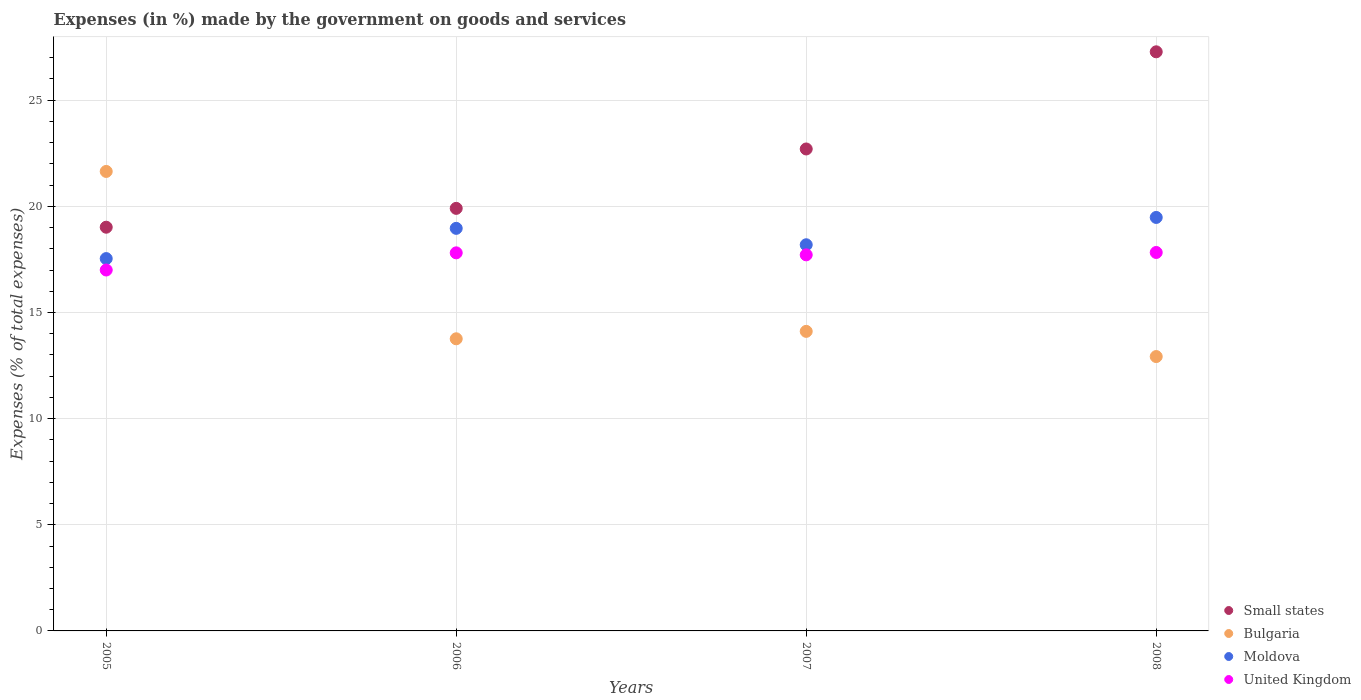Is the number of dotlines equal to the number of legend labels?
Your response must be concise. Yes. What is the percentage of expenses made by the government on goods and services in United Kingdom in 2006?
Give a very brief answer. 17.81. Across all years, what is the maximum percentage of expenses made by the government on goods and services in United Kingdom?
Provide a succinct answer. 17.83. Across all years, what is the minimum percentage of expenses made by the government on goods and services in Bulgaria?
Make the answer very short. 12.92. What is the total percentage of expenses made by the government on goods and services in Moldova in the graph?
Offer a very short reply. 74.17. What is the difference between the percentage of expenses made by the government on goods and services in Moldova in 2007 and that in 2008?
Provide a short and direct response. -1.29. What is the difference between the percentage of expenses made by the government on goods and services in Small states in 2005 and the percentage of expenses made by the government on goods and services in Bulgaria in 2007?
Offer a terse response. 4.91. What is the average percentage of expenses made by the government on goods and services in Small states per year?
Offer a very short reply. 22.22. In the year 2008, what is the difference between the percentage of expenses made by the government on goods and services in United Kingdom and percentage of expenses made by the government on goods and services in Bulgaria?
Make the answer very short. 4.9. What is the ratio of the percentage of expenses made by the government on goods and services in Bulgaria in 2006 to that in 2008?
Provide a succinct answer. 1.06. Is the percentage of expenses made by the government on goods and services in Moldova in 2007 less than that in 2008?
Offer a terse response. Yes. What is the difference between the highest and the second highest percentage of expenses made by the government on goods and services in United Kingdom?
Your answer should be very brief. 0.02. What is the difference between the highest and the lowest percentage of expenses made by the government on goods and services in United Kingdom?
Provide a short and direct response. 0.83. Does the percentage of expenses made by the government on goods and services in United Kingdom monotonically increase over the years?
Your response must be concise. No. Is the percentage of expenses made by the government on goods and services in United Kingdom strictly greater than the percentage of expenses made by the government on goods and services in Moldova over the years?
Make the answer very short. No. Is the percentage of expenses made by the government on goods and services in Small states strictly less than the percentage of expenses made by the government on goods and services in Moldova over the years?
Provide a short and direct response. No. How many dotlines are there?
Your response must be concise. 4. How many years are there in the graph?
Provide a succinct answer. 4. What is the difference between two consecutive major ticks on the Y-axis?
Your answer should be very brief. 5. Are the values on the major ticks of Y-axis written in scientific E-notation?
Provide a short and direct response. No. Does the graph contain any zero values?
Ensure brevity in your answer.  No. Does the graph contain grids?
Give a very brief answer. Yes. How are the legend labels stacked?
Ensure brevity in your answer.  Vertical. What is the title of the graph?
Provide a short and direct response. Expenses (in %) made by the government on goods and services. Does "Monaco" appear as one of the legend labels in the graph?
Provide a short and direct response. No. What is the label or title of the X-axis?
Provide a short and direct response. Years. What is the label or title of the Y-axis?
Ensure brevity in your answer.  Expenses (% of total expenses). What is the Expenses (% of total expenses) of Small states in 2005?
Make the answer very short. 19.02. What is the Expenses (% of total expenses) in Bulgaria in 2005?
Give a very brief answer. 21.64. What is the Expenses (% of total expenses) in Moldova in 2005?
Your answer should be very brief. 17.54. What is the Expenses (% of total expenses) of United Kingdom in 2005?
Keep it short and to the point. 17. What is the Expenses (% of total expenses) in Small states in 2006?
Ensure brevity in your answer.  19.9. What is the Expenses (% of total expenses) of Bulgaria in 2006?
Give a very brief answer. 13.76. What is the Expenses (% of total expenses) of Moldova in 2006?
Provide a succinct answer. 18.96. What is the Expenses (% of total expenses) of United Kingdom in 2006?
Keep it short and to the point. 17.81. What is the Expenses (% of total expenses) in Small states in 2007?
Offer a terse response. 22.7. What is the Expenses (% of total expenses) of Bulgaria in 2007?
Keep it short and to the point. 14.11. What is the Expenses (% of total expenses) in Moldova in 2007?
Provide a succinct answer. 18.19. What is the Expenses (% of total expenses) in United Kingdom in 2007?
Your answer should be compact. 17.71. What is the Expenses (% of total expenses) of Small states in 2008?
Your response must be concise. 27.28. What is the Expenses (% of total expenses) of Bulgaria in 2008?
Offer a terse response. 12.92. What is the Expenses (% of total expenses) of Moldova in 2008?
Provide a succinct answer. 19.48. What is the Expenses (% of total expenses) of United Kingdom in 2008?
Your answer should be very brief. 17.83. Across all years, what is the maximum Expenses (% of total expenses) in Small states?
Make the answer very short. 27.28. Across all years, what is the maximum Expenses (% of total expenses) in Bulgaria?
Keep it short and to the point. 21.64. Across all years, what is the maximum Expenses (% of total expenses) of Moldova?
Your response must be concise. 19.48. Across all years, what is the maximum Expenses (% of total expenses) in United Kingdom?
Your answer should be very brief. 17.83. Across all years, what is the minimum Expenses (% of total expenses) of Small states?
Provide a succinct answer. 19.02. Across all years, what is the minimum Expenses (% of total expenses) of Bulgaria?
Your response must be concise. 12.92. Across all years, what is the minimum Expenses (% of total expenses) in Moldova?
Keep it short and to the point. 17.54. Across all years, what is the minimum Expenses (% of total expenses) in United Kingdom?
Your answer should be compact. 17. What is the total Expenses (% of total expenses) in Small states in the graph?
Ensure brevity in your answer.  88.9. What is the total Expenses (% of total expenses) of Bulgaria in the graph?
Your answer should be very brief. 62.44. What is the total Expenses (% of total expenses) of Moldova in the graph?
Keep it short and to the point. 74.17. What is the total Expenses (% of total expenses) in United Kingdom in the graph?
Your answer should be compact. 70.35. What is the difference between the Expenses (% of total expenses) in Small states in 2005 and that in 2006?
Ensure brevity in your answer.  -0.89. What is the difference between the Expenses (% of total expenses) of Bulgaria in 2005 and that in 2006?
Your answer should be very brief. 7.88. What is the difference between the Expenses (% of total expenses) in Moldova in 2005 and that in 2006?
Your answer should be very brief. -1.42. What is the difference between the Expenses (% of total expenses) of United Kingdom in 2005 and that in 2006?
Offer a terse response. -0.81. What is the difference between the Expenses (% of total expenses) of Small states in 2005 and that in 2007?
Give a very brief answer. -3.69. What is the difference between the Expenses (% of total expenses) in Bulgaria in 2005 and that in 2007?
Offer a very short reply. 7.53. What is the difference between the Expenses (% of total expenses) of Moldova in 2005 and that in 2007?
Provide a succinct answer. -0.65. What is the difference between the Expenses (% of total expenses) of United Kingdom in 2005 and that in 2007?
Ensure brevity in your answer.  -0.71. What is the difference between the Expenses (% of total expenses) in Small states in 2005 and that in 2008?
Keep it short and to the point. -8.26. What is the difference between the Expenses (% of total expenses) in Bulgaria in 2005 and that in 2008?
Your answer should be very brief. 8.72. What is the difference between the Expenses (% of total expenses) of Moldova in 2005 and that in 2008?
Your answer should be compact. -1.94. What is the difference between the Expenses (% of total expenses) in United Kingdom in 2005 and that in 2008?
Provide a short and direct response. -0.83. What is the difference between the Expenses (% of total expenses) of Small states in 2006 and that in 2007?
Provide a succinct answer. -2.8. What is the difference between the Expenses (% of total expenses) in Bulgaria in 2006 and that in 2007?
Make the answer very short. -0.35. What is the difference between the Expenses (% of total expenses) in Moldova in 2006 and that in 2007?
Make the answer very short. 0.77. What is the difference between the Expenses (% of total expenses) of United Kingdom in 2006 and that in 2007?
Your answer should be compact. 0.09. What is the difference between the Expenses (% of total expenses) of Small states in 2006 and that in 2008?
Give a very brief answer. -7.37. What is the difference between the Expenses (% of total expenses) of Bulgaria in 2006 and that in 2008?
Ensure brevity in your answer.  0.84. What is the difference between the Expenses (% of total expenses) in Moldova in 2006 and that in 2008?
Ensure brevity in your answer.  -0.51. What is the difference between the Expenses (% of total expenses) of United Kingdom in 2006 and that in 2008?
Give a very brief answer. -0.02. What is the difference between the Expenses (% of total expenses) in Small states in 2007 and that in 2008?
Give a very brief answer. -4.58. What is the difference between the Expenses (% of total expenses) in Bulgaria in 2007 and that in 2008?
Keep it short and to the point. 1.19. What is the difference between the Expenses (% of total expenses) of Moldova in 2007 and that in 2008?
Keep it short and to the point. -1.29. What is the difference between the Expenses (% of total expenses) of United Kingdom in 2007 and that in 2008?
Make the answer very short. -0.11. What is the difference between the Expenses (% of total expenses) in Small states in 2005 and the Expenses (% of total expenses) in Bulgaria in 2006?
Provide a succinct answer. 5.26. What is the difference between the Expenses (% of total expenses) in Small states in 2005 and the Expenses (% of total expenses) in Moldova in 2006?
Your answer should be very brief. 0.05. What is the difference between the Expenses (% of total expenses) in Small states in 2005 and the Expenses (% of total expenses) in United Kingdom in 2006?
Keep it short and to the point. 1.21. What is the difference between the Expenses (% of total expenses) of Bulgaria in 2005 and the Expenses (% of total expenses) of Moldova in 2006?
Offer a very short reply. 2.68. What is the difference between the Expenses (% of total expenses) in Bulgaria in 2005 and the Expenses (% of total expenses) in United Kingdom in 2006?
Offer a very short reply. 3.83. What is the difference between the Expenses (% of total expenses) of Moldova in 2005 and the Expenses (% of total expenses) of United Kingdom in 2006?
Make the answer very short. -0.27. What is the difference between the Expenses (% of total expenses) of Small states in 2005 and the Expenses (% of total expenses) of Bulgaria in 2007?
Provide a short and direct response. 4.91. What is the difference between the Expenses (% of total expenses) of Small states in 2005 and the Expenses (% of total expenses) of Moldova in 2007?
Offer a very short reply. 0.83. What is the difference between the Expenses (% of total expenses) of Small states in 2005 and the Expenses (% of total expenses) of United Kingdom in 2007?
Your response must be concise. 1.3. What is the difference between the Expenses (% of total expenses) in Bulgaria in 2005 and the Expenses (% of total expenses) in Moldova in 2007?
Your answer should be compact. 3.45. What is the difference between the Expenses (% of total expenses) of Bulgaria in 2005 and the Expenses (% of total expenses) of United Kingdom in 2007?
Provide a succinct answer. 3.93. What is the difference between the Expenses (% of total expenses) of Moldova in 2005 and the Expenses (% of total expenses) of United Kingdom in 2007?
Your answer should be compact. -0.18. What is the difference between the Expenses (% of total expenses) in Small states in 2005 and the Expenses (% of total expenses) in Bulgaria in 2008?
Give a very brief answer. 6.09. What is the difference between the Expenses (% of total expenses) in Small states in 2005 and the Expenses (% of total expenses) in Moldova in 2008?
Keep it short and to the point. -0.46. What is the difference between the Expenses (% of total expenses) of Small states in 2005 and the Expenses (% of total expenses) of United Kingdom in 2008?
Provide a succinct answer. 1.19. What is the difference between the Expenses (% of total expenses) of Bulgaria in 2005 and the Expenses (% of total expenses) of Moldova in 2008?
Your answer should be compact. 2.17. What is the difference between the Expenses (% of total expenses) of Bulgaria in 2005 and the Expenses (% of total expenses) of United Kingdom in 2008?
Offer a very short reply. 3.82. What is the difference between the Expenses (% of total expenses) of Moldova in 2005 and the Expenses (% of total expenses) of United Kingdom in 2008?
Give a very brief answer. -0.29. What is the difference between the Expenses (% of total expenses) in Small states in 2006 and the Expenses (% of total expenses) in Bulgaria in 2007?
Make the answer very short. 5.79. What is the difference between the Expenses (% of total expenses) in Small states in 2006 and the Expenses (% of total expenses) in Moldova in 2007?
Your response must be concise. 1.71. What is the difference between the Expenses (% of total expenses) in Small states in 2006 and the Expenses (% of total expenses) in United Kingdom in 2007?
Keep it short and to the point. 2.19. What is the difference between the Expenses (% of total expenses) of Bulgaria in 2006 and the Expenses (% of total expenses) of Moldova in 2007?
Ensure brevity in your answer.  -4.43. What is the difference between the Expenses (% of total expenses) of Bulgaria in 2006 and the Expenses (% of total expenses) of United Kingdom in 2007?
Your answer should be very brief. -3.95. What is the difference between the Expenses (% of total expenses) of Moldova in 2006 and the Expenses (% of total expenses) of United Kingdom in 2007?
Your response must be concise. 1.25. What is the difference between the Expenses (% of total expenses) in Small states in 2006 and the Expenses (% of total expenses) in Bulgaria in 2008?
Offer a very short reply. 6.98. What is the difference between the Expenses (% of total expenses) in Small states in 2006 and the Expenses (% of total expenses) in Moldova in 2008?
Provide a short and direct response. 0.43. What is the difference between the Expenses (% of total expenses) of Small states in 2006 and the Expenses (% of total expenses) of United Kingdom in 2008?
Provide a succinct answer. 2.08. What is the difference between the Expenses (% of total expenses) of Bulgaria in 2006 and the Expenses (% of total expenses) of Moldova in 2008?
Offer a terse response. -5.72. What is the difference between the Expenses (% of total expenses) of Bulgaria in 2006 and the Expenses (% of total expenses) of United Kingdom in 2008?
Make the answer very short. -4.07. What is the difference between the Expenses (% of total expenses) in Moldova in 2006 and the Expenses (% of total expenses) in United Kingdom in 2008?
Ensure brevity in your answer.  1.14. What is the difference between the Expenses (% of total expenses) in Small states in 2007 and the Expenses (% of total expenses) in Bulgaria in 2008?
Give a very brief answer. 9.78. What is the difference between the Expenses (% of total expenses) of Small states in 2007 and the Expenses (% of total expenses) of Moldova in 2008?
Ensure brevity in your answer.  3.23. What is the difference between the Expenses (% of total expenses) in Small states in 2007 and the Expenses (% of total expenses) in United Kingdom in 2008?
Keep it short and to the point. 4.88. What is the difference between the Expenses (% of total expenses) in Bulgaria in 2007 and the Expenses (% of total expenses) in Moldova in 2008?
Give a very brief answer. -5.37. What is the difference between the Expenses (% of total expenses) in Bulgaria in 2007 and the Expenses (% of total expenses) in United Kingdom in 2008?
Your answer should be compact. -3.72. What is the difference between the Expenses (% of total expenses) in Moldova in 2007 and the Expenses (% of total expenses) in United Kingdom in 2008?
Provide a short and direct response. 0.36. What is the average Expenses (% of total expenses) of Small states per year?
Give a very brief answer. 22.22. What is the average Expenses (% of total expenses) of Bulgaria per year?
Your answer should be compact. 15.61. What is the average Expenses (% of total expenses) of Moldova per year?
Give a very brief answer. 18.54. What is the average Expenses (% of total expenses) of United Kingdom per year?
Ensure brevity in your answer.  17.59. In the year 2005, what is the difference between the Expenses (% of total expenses) of Small states and Expenses (% of total expenses) of Bulgaria?
Give a very brief answer. -2.63. In the year 2005, what is the difference between the Expenses (% of total expenses) of Small states and Expenses (% of total expenses) of Moldova?
Keep it short and to the point. 1.48. In the year 2005, what is the difference between the Expenses (% of total expenses) of Small states and Expenses (% of total expenses) of United Kingdom?
Ensure brevity in your answer.  2.02. In the year 2005, what is the difference between the Expenses (% of total expenses) in Bulgaria and Expenses (% of total expenses) in Moldova?
Your answer should be very brief. 4.1. In the year 2005, what is the difference between the Expenses (% of total expenses) of Bulgaria and Expenses (% of total expenses) of United Kingdom?
Your answer should be very brief. 4.64. In the year 2005, what is the difference between the Expenses (% of total expenses) in Moldova and Expenses (% of total expenses) in United Kingdom?
Keep it short and to the point. 0.54. In the year 2006, what is the difference between the Expenses (% of total expenses) in Small states and Expenses (% of total expenses) in Bulgaria?
Your answer should be very brief. 6.14. In the year 2006, what is the difference between the Expenses (% of total expenses) of Small states and Expenses (% of total expenses) of Moldova?
Provide a short and direct response. 0.94. In the year 2006, what is the difference between the Expenses (% of total expenses) in Small states and Expenses (% of total expenses) in United Kingdom?
Keep it short and to the point. 2.1. In the year 2006, what is the difference between the Expenses (% of total expenses) in Bulgaria and Expenses (% of total expenses) in Moldova?
Ensure brevity in your answer.  -5.2. In the year 2006, what is the difference between the Expenses (% of total expenses) in Bulgaria and Expenses (% of total expenses) in United Kingdom?
Give a very brief answer. -4.05. In the year 2006, what is the difference between the Expenses (% of total expenses) in Moldova and Expenses (% of total expenses) in United Kingdom?
Ensure brevity in your answer.  1.15. In the year 2007, what is the difference between the Expenses (% of total expenses) of Small states and Expenses (% of total expenses) of Bulgaria?
Ensure brevity in your answer.  8.59. In the year 2007, what is the difference between the Expenses (% of total expenses) of Small states and Expenses (% of total expenses) of Moldova?
Your answer should be very brief. 4.51. In the year 2007, what is the difference between the Expenses (% of total expenses) in Small states and Expenses (% of total expenses) in United Kingdom?
Offer a terse response. 4.99. In the year 2007, what is the difference between the Expenses (% of total expenses) of Bulgaria and Expenses (% of total expenses) of Moldova?
Provide a short and direct response. -4.08. In the year 2007, what is the difference between the Expenses (% of total expenses) of Bulgaria and Expenses (% of total expenses) of United Kingdom?
Ensure brevity in your answer.  -3.6. In the year 2007, what is the difference between the Expenses (% of total expenses) in Moldova and Expenses (% of total expenses) in United Kingdom?
Your answer should be very brief. 0.48. In the year 2008, what is the difference between the Expenses (% of total expenses) in Small states and Expenses (% of total expenses) in Bulgaria?
Keep it short and to the point. 14.35. In the year 2008, what is the difference between the Expenses (% of total expenses) in Small states and Expenses (% of total expenses) in Moldova?
Provide a succinct answer. 7.8. In the year 2008, what is the difference between the Expenses (% of total expenses) of Small states and Expenses (% of total expenses) of United Kingdom?
Your response must be concise. 9.45. In the year 2008, what is the difference between the Expenses (% of total expenses) of Bulgaria and Expenses (% of total expenses) of Moldova?
Make the answer very short. -6.55. In the year 2008, what is the difference between the Expenses (% of total expenses) in Bulgaria and Expenses (% of total expenses) in United Kingdom?
Give a very brief answer. -4.9. In the year 2008, what is the difference between the Expenses (% of total expenses) in Moldova and Expenses (% of total expenses) in United Kingdom?
Your response must be concise. 1.65. What is the ratio of the Expenses (% of total expenses) of Small states in 2005 to that in 2006?
Ensure brevity in your answer.  0.96. What is the ratio of the Expenses (% of total expenses) of Bulgaria in 2005 to that in 2006?
Give a very brief answer. 1.57. What is the ratio of the Expenses (% of total expenses) in Moldova in 2005 to that in 2006?
Your answer should be very brief. 0.92. What is the ratio of the Expenses (% of total expenses) of United Kingdom in 2005 to that in 2006?
Ensure brevity in your answer.  0.95. What is the ratio of the Expenses (% of total expenses) of Small states in 2005 to that in 2007?
Your answer should be compact. 0.84. What is the ratio of the Expenses (% of total expenses) in Bulgaria in 2005 to that in 2007?
Make the answer very short. 1.53. What is the ratio of the Expenses (% of total expenses) in Moldova in 2005 to that in 2007?
Keep it short and to the point. 0.96. What is the ratio of the Expenses (% of total expenses) of United Kingdom in 2005 to that in 2007?
Offer a terse response. 0.96. What is the ratio of the Expenses (% of total expenses) of Small states in 2005 to that in 2008?
Provide a short and direct response. 0.7. What is the ratio of the Expenses (% of total expenses) in Bulgaria in 2005 to that in 2008?
Provide a short and direct response. 1.67. What is the ratio of the Expenses (% of total expenses) of Moldova in 2005 to that in 2008?
Give a very brief answer. 0.9. What is the ratio of the Expenses (% of total expenses) in United Kingdom in 2005 to that in 2008?
Give a very brief answer. 0.95. What is the ratio of the Expenses (% of total expenses) of Small states in 2006 to that in 2007?
Offer a very short reply. 0.88. What is the ratio of the Expenses (% of total expenses) of Bulgaria in 2006 to that in 2007?
Ensure brevity in your answer.  0.98. What is the ratio of the Expenses (% of total expenses) in Moldova in 2006 to that in 2007?
Offer a very short reply. 1.04. What is the ratio of the Expenses (% of total expenses) of Small states in 2006 to that in 2008?
Offer a very short reply. 0.73. What is the ratio of the Expenses (% of total expenses) of Bulgaria in 2006 to that in 2008?
Provide a succinct answer. 1.06. What is the ratio of the Expenses (% of total expenses) in Moldova in 2006 to that in 2008?
Provide a succinct answer. 0.97. What is the ratio of the Expenses (% of total expenses) in United Kingdom in 2006 to that in 2008?
Provide a short and direct response. 1. What is the ratio of the Expenses (% of total expenses) of Small states in 2007 to that in 2008?
Give a very brief answer. 0.83. What is the ratio of the Expenses (% of total expenses) of Bulgaria in 2007 to that in 2008?
Make the answer very short. 1.09. What is the ratio of the Expenses (% of total expenses) of Moldova in 2007 to that in 2008?
Provide a short and direct response. 0.93. What is the ratio of the Expenses (% of total expenses) of United Kingdom in 2007 to that in 2008?
Ensure brevity in your answer.  0.99. What is the difference between the highest and the second highest Expenses (% of total expenses) in Small states?
Your answer should be compact. 4.58. What is the difference between the highest and the second highest Expenses (% of total expenses) of Bulgaria?
Provide a succinct answer. 7.53. What is the difference between the highest and the second highest Expenses (% of total expenses) of Moldova?
Keep it short and to the point. 0.51. What is the difference between the highest and the second highest Expenses (% of total expenses) in United Kingdom?
Keep it short and to the point. 0.02. What is the difference between the highest and the lowest Expenses (% of total expenses) in Small states?
Provide a short and direct response. 8.26. What is the difference between the highest and the lowest Expenses (% of total expenses) of Bulgaria?
Make the answer very short. 8.72. What is the difference between the highest and the lowest Expenses (% of total expenses) of Moldova?
Ensure brevity in your answer.  1.94. What is the difference between the highest and the lowest Expenses (% of total expenses) in United Kingdom?
Offer a very short reply. 0.83. 